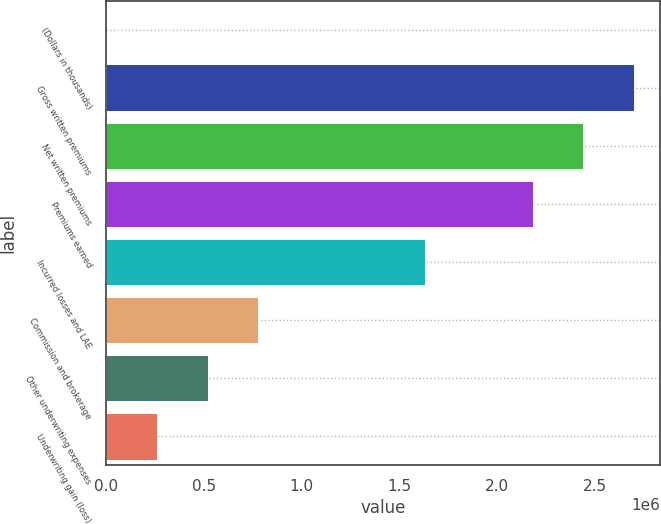Convert chart to OTSL. <chart><loc_0><loc_0><loc_500><loc_500><bar_chart><fcel>(Dollars in thousands)<fcel>Gross written premiums<fcel>Net written premiums<fcel>Premiums earned<fcel>Incurred losses and LAE<fcel>Commission and brokerage<fcel>Other underwriting expenses<fcel>Underwriting gain (loss)<nl><fcel>2017<fcel>2.69935e+06<fcel>2.44026e+06<fcel>2.18116e+06<fcel>1.6328e+06<fcel>779304<fcel>520208<fcel>261112<nl></chart> 